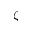<formula> <loc_0><loc_0><loc_500><loc_500>\zeta</formula> 